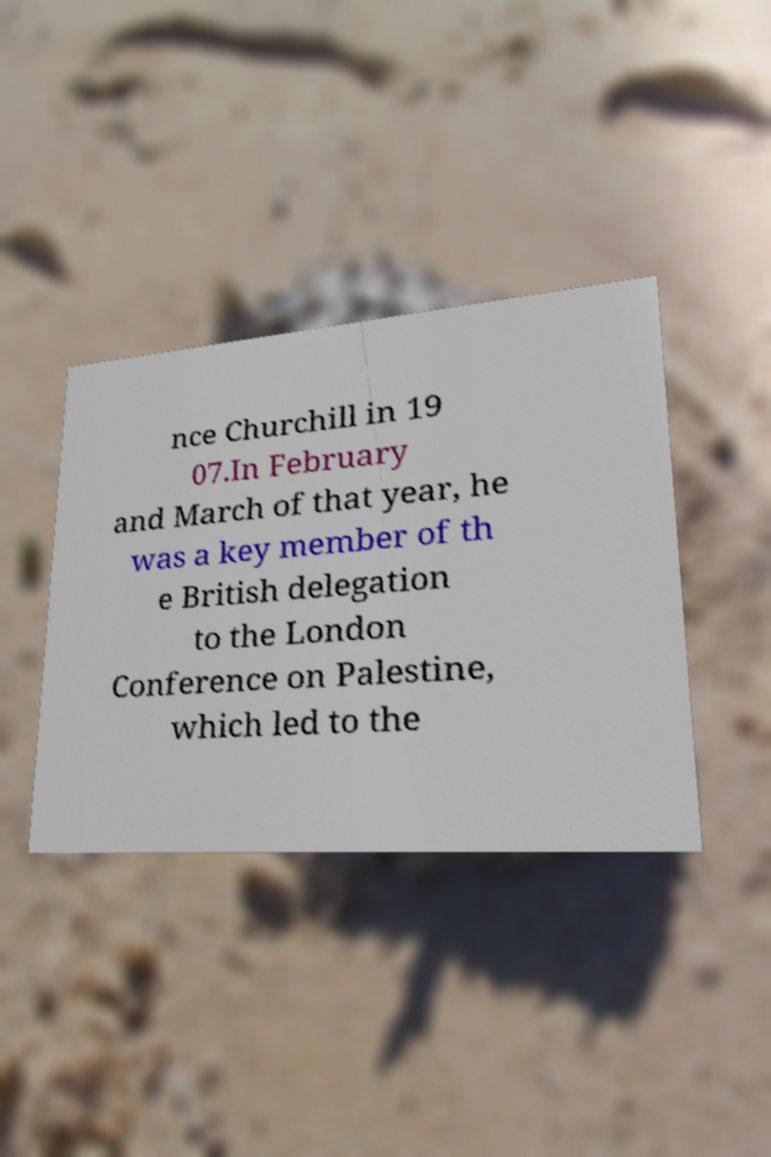There's text embedded in this image that I need extracted. Can you transcribe it verbatim? nce Churchill in 19 07.In February and March of that year, he was a key member of th e British delegation to the London Conference on Palestine, which led to the 